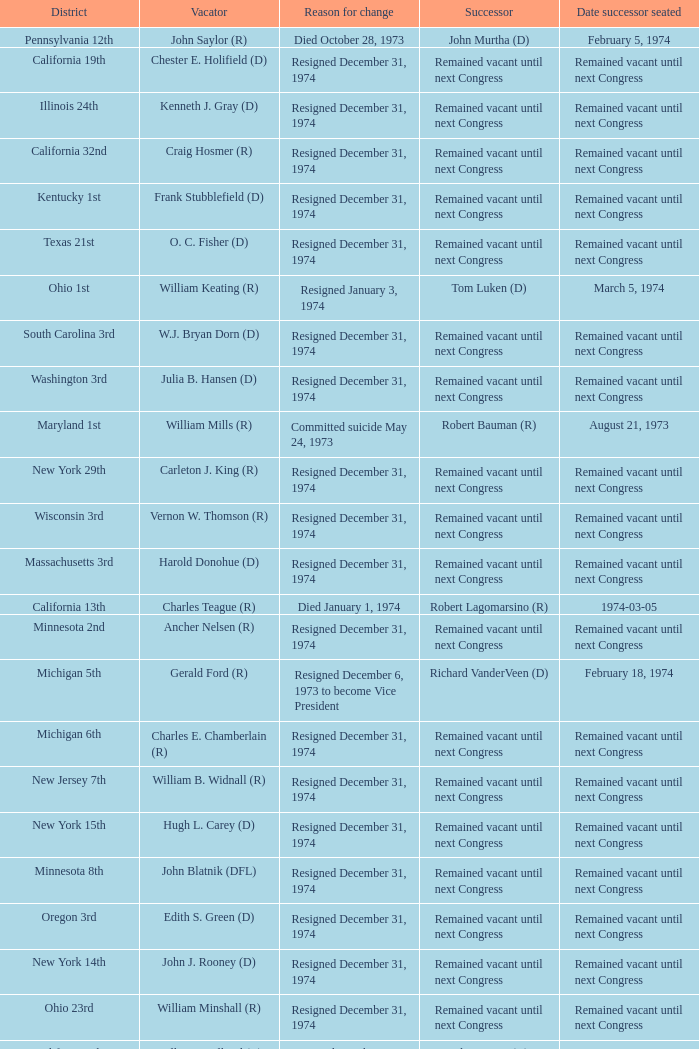Who was the successor when the vacator was chester e. holifield (d)? Remained vacant until next Congress. 